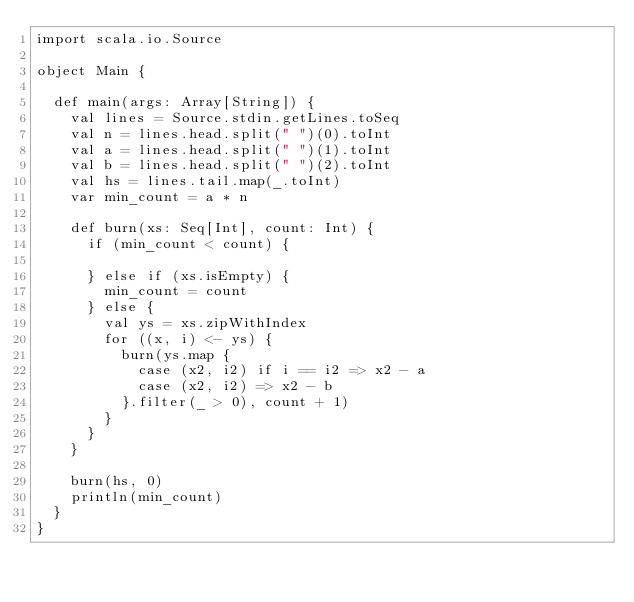Convert code to text. <code><loc_0><loc_0><loc_500><loc_500><_Scala_>import scala.io.Source

object Main {

  def main(args: Array[String]) {
    val lines = Source.stdin.getLines.toSeq
    val n = lines.head.split(" ")(0).toInt
    val a = lines.head.split(" ")(1).toInt
    val b = lines.head.split(" ")(2).toInt
    val hs = lines.tail.map(_.toInt)
    var min_count = a * n

    def burn(xs: Seq[Int], count: Int) {
      if (min_count < count) {

      } else if (xs.isEmpty) {
        min_count = count
      } else {
        val ys = xs.zipWithIndex
        for ((x, i) <- ys) {
          burn(ys.map {
            case (x2, i2) if i == i2 => x2 - a
            case (x2, i2) => x2 - b
          }.filter(_ > 0), count + 1)
        }
      }
    }

    burn(hs, 0)
    println(min_count)
  }
}
</code> 